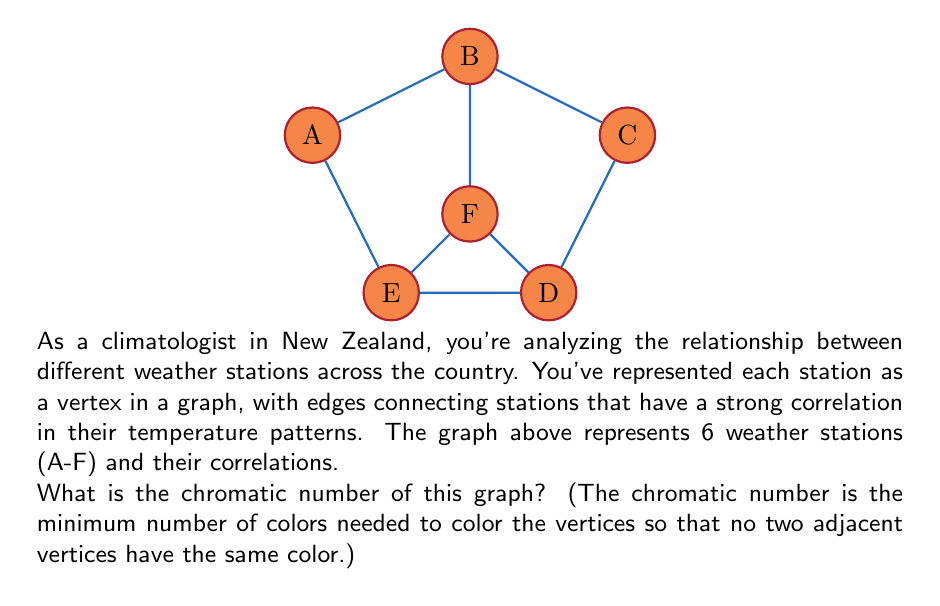Solve this math problem. To find the chromatic number, we'll use a greedy coloring algorithm and then prove it's optimal:

1) Start with station A. Color it red.

2) Move to B. It's connected to A, so it needs a new color. Color it blue.

3) For C:
   - Connected to B, can't be blue
   - Not connected to A, can be red
   Color C red.

4) For D:
   - Connected to C (red) and B (blue)
   - Needs a new color. Color it green.

5) For E:
   - Connected to A (red) and D (green)
   - Can be colored blue.

6) For F:
   - Connected to B (blue), D (green), and E (blue)
   - Must be colored red.

We've used 3 colors: red, blue, and green.

To prove this is optimal:
- Notice that vertices B, D, and F form a triangle (a cycle of length 3).
- In any proper coloring, each of these vertices must have a different color.
- Therefore, at least 3 colors are necessary.

Since we found a coloring with 3 colors and proved that at least 3 colors are necessary, the chromatic number is exactly 3.

This analysis helps climatologists understand the complexity of temperature pattern relationships across different regions in New Zealand.
Answer: 3 